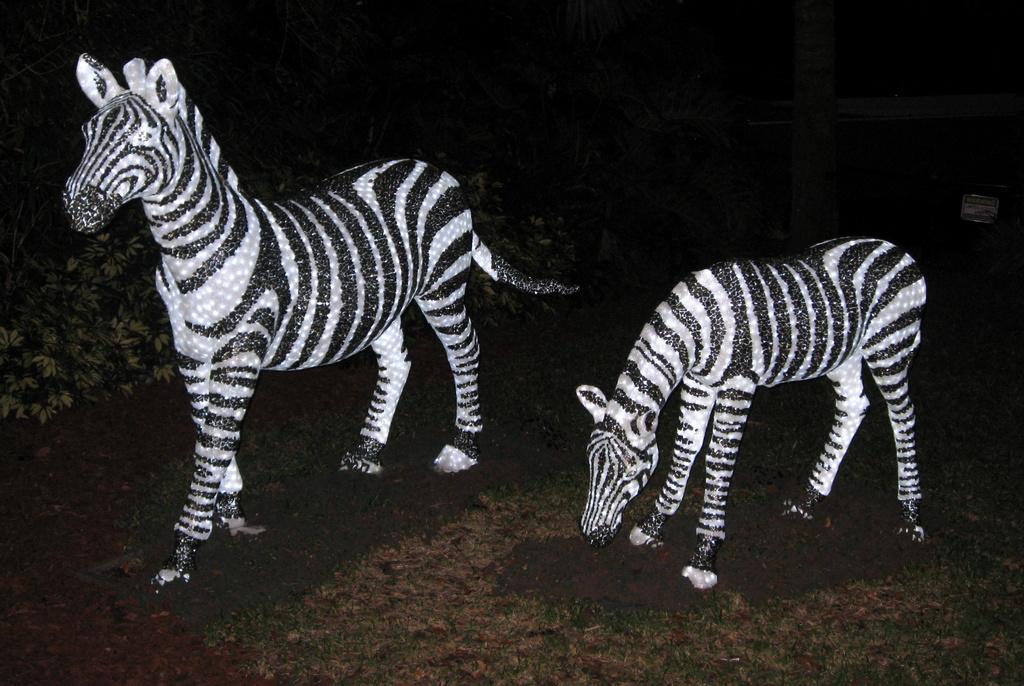In one or two sentences, can you explain what this image depicts? On the left side, there is a statue of a zebra on the ground. On the right side, there is another zebra on the ground. In the background, there are plants. And the background is dark in color. 